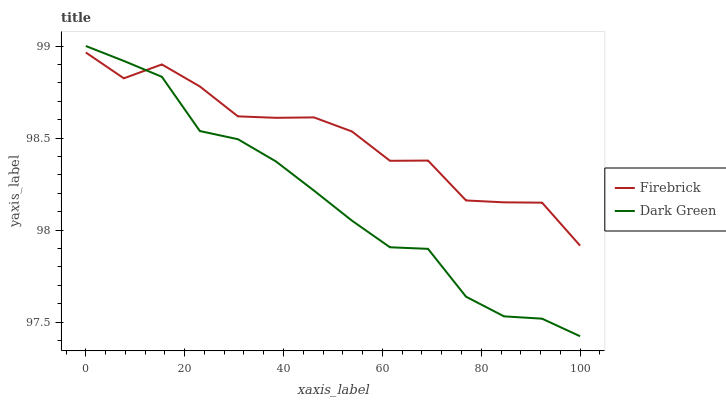Does Dark Green have the minimum area under the curve?
Answer yes or no. Yes. Does Firebrick have the maximum area under the curve?
Answer yes or no. Yes. Does Dark Green have the maximum area under the curve?
Answer yes or no. No. Is Dark Green the smoothest?
Answer yes or no. Yes. Is Firebrick the roughest?
Answer yes or no. Yes. Is Dark Green the roughest?
Answer yes or no. No. Does Dark Green have the highest value?
Answer yes or no. Yes. Does Firebrick intersect Dark Green?
Answer yes or no. Yes. Is Firebrick less than Dark Green?
Answer yes or no. No. Is Firebrick greater than Dark Green?
Answer yes or no. No. 